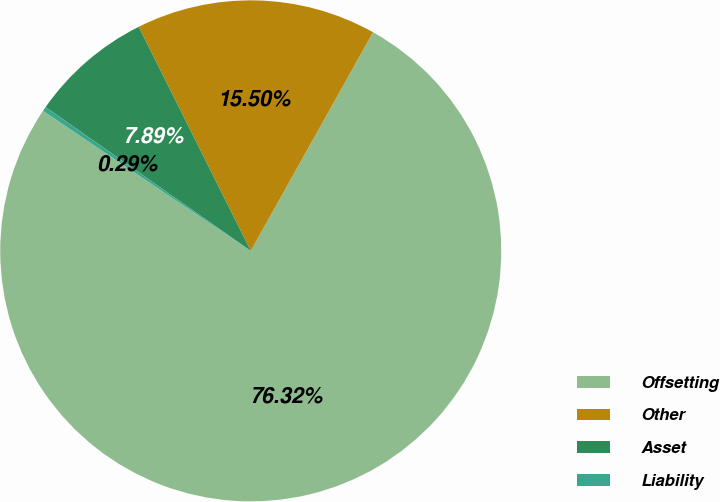<chart> <loc_0><loc_0><loc_500><loc_500><pie_chart><fcel>Offsetting<fcel>Other<fcel>Asset<fcel>Liability<nl><fcel>76.32%<fcel>15.5%<fcel>7.89%<fcel>0.29%<nl></chart> 